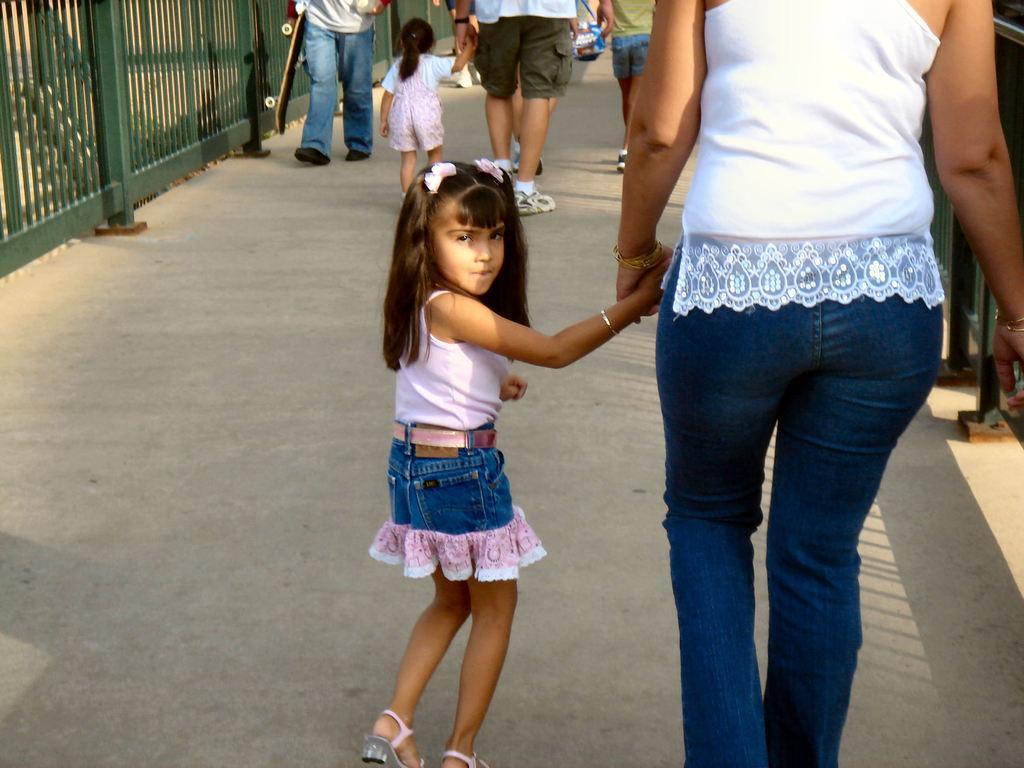How would you summarize this image in a sentence or two? On the right side of this image I can see a woman wearing a white color t-shirt, jeans and holding the hand of a girl who is beside her. Both are walking on the road. In the background, I can see some more people. On both sides of the road I can see the railings. 